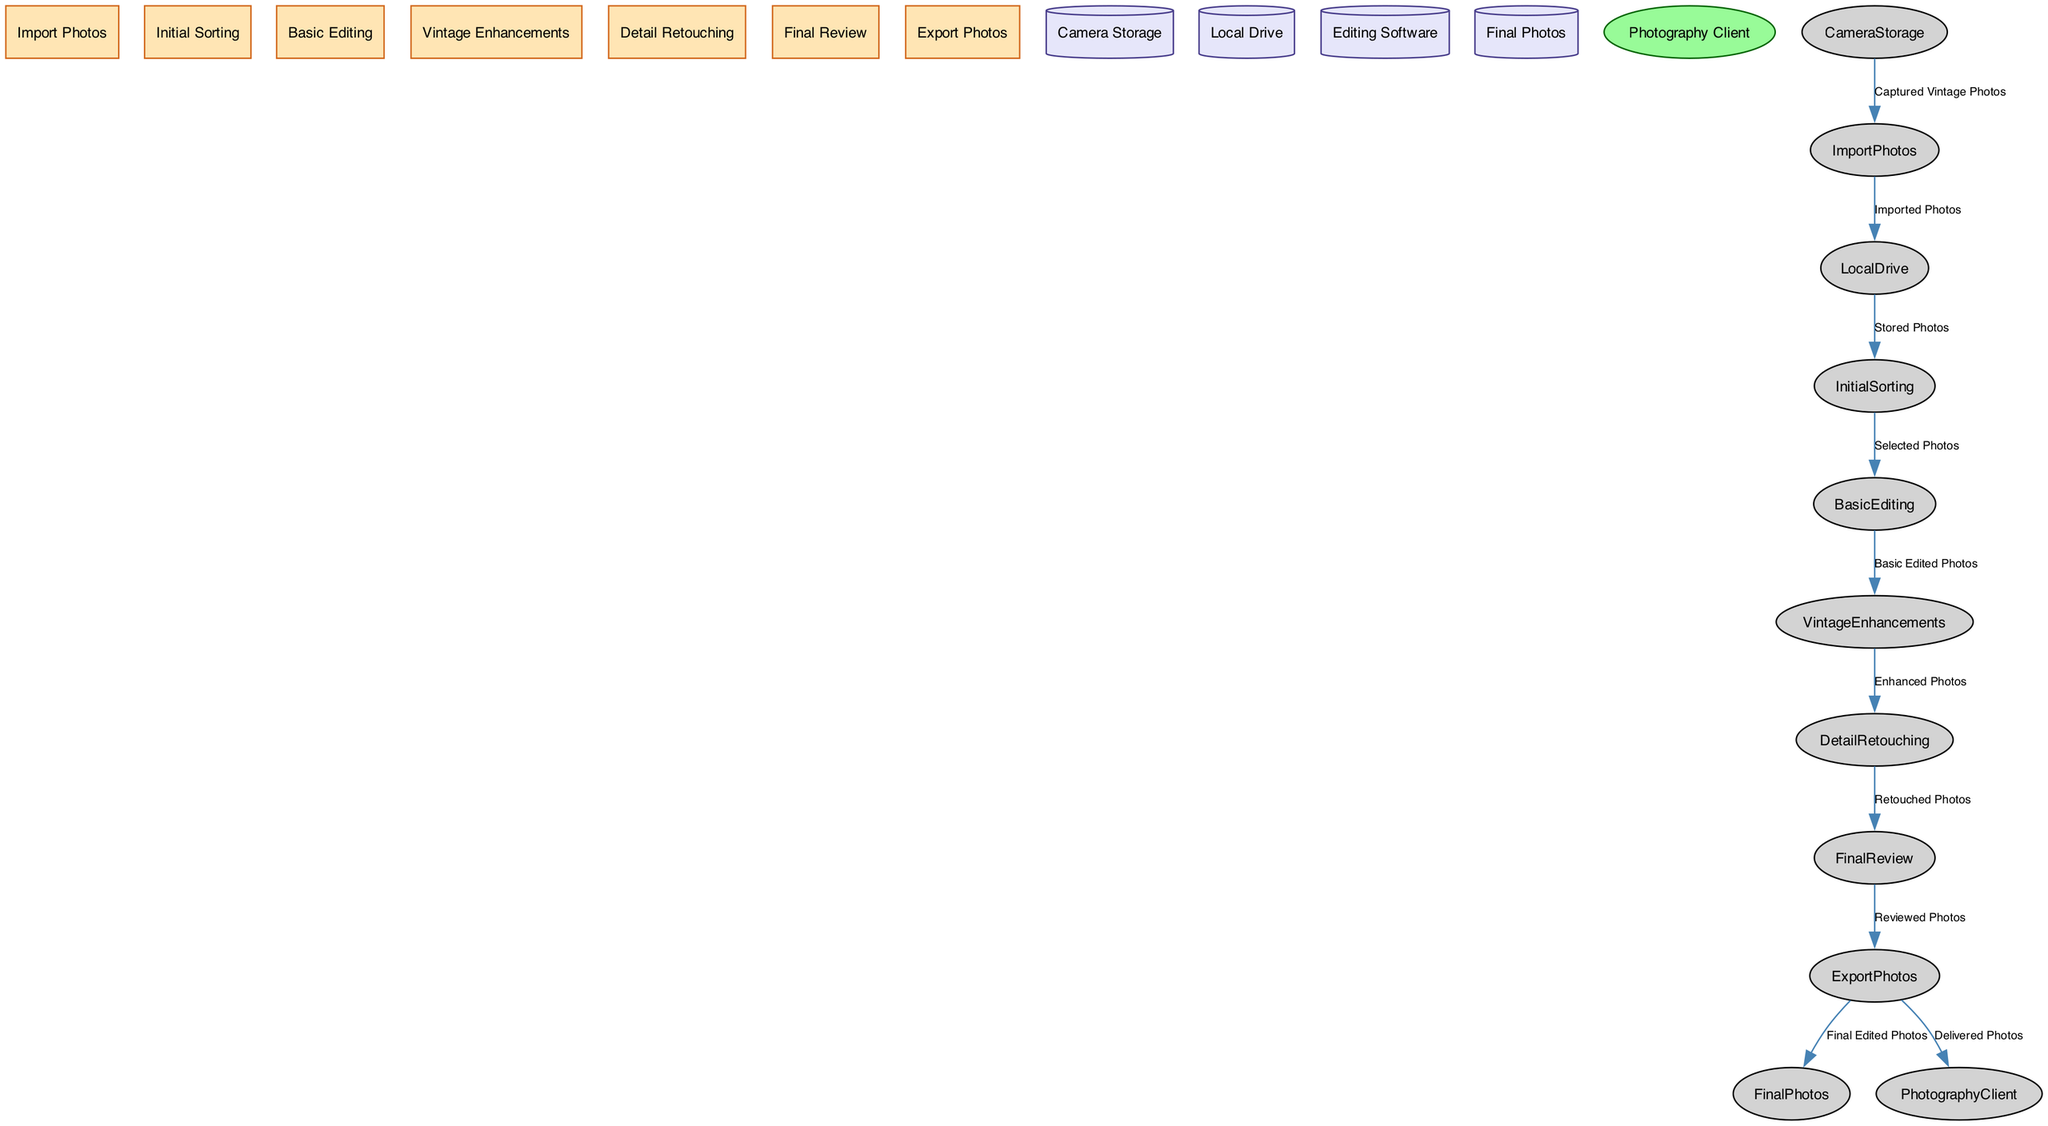What is the first process in the workflow? The first process listed is "Import Photos," which indicates the initial action taken in the workflow.
Answer: Import Photos How many data stores are present in the diagram? There are four data stores identified: Camera Storage, Local Drive, Editing Software, and Final Photos.
Answer: Four Which process comes after "Basic Editing"? After "Basic Editing," the next process is "Vintage Enhancements," indicating a sequential flow in the editing workflow.
Answer: Vintage Enhancements What data flows from the "Detail Retouching" process? The data that flows from "Detail Retouching" is labeled as "Retouched Photos," which refers to the output of that specific editing phase.
Answer: Retouched Photos Who receives the final edited photos? The "Photography Client" is the external entity that receives the final edited photos, as indicated by the data flow leading to this external entity.
Answer: Photography Client How many processes are involved in the workflow? There are six processes involved in the workflow: Import Photos, Initial Sorting, Basic Editing, Vintage Enhancements, Detail Retouching, Final Review, and Export Photos.
Answer: Six What type of diagram is represented? The diagram is a Data Flow Diagram, which specifically illustrates the flow of data through a process or system.
Answer: Data Flow Diagram Which data store is used for storing the imported photos? The data store used for storing imported photos is the "Local Drive," where photos are kept after the import process.
Answer: Local Drive What label is associated with the edge from "Export Photos" to "Final Photos"? The label for the edge going from "Export Photos" to "Final Photos" is "Final Edited Photos," indicating the outcome of the export process.
Answer: Final Edited Photos 